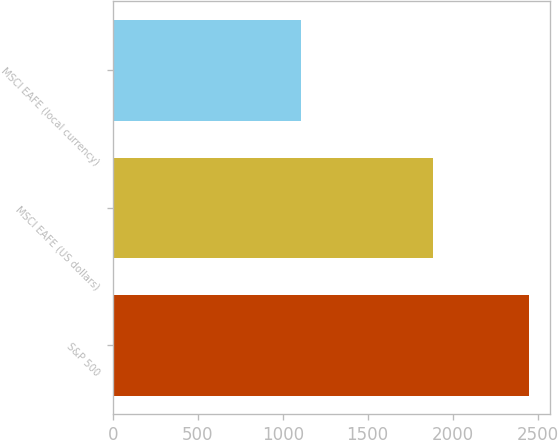Convert chart to OTSL. <chart><loc_0><loc_0><loc_500><loc_500><bar_chart><fcel>S&P 500<fcel>MSCI EAFE (US dollars)<fcel>MSCI EAFE (local currency)<nl><fcel>2448<fcel>1886<fcel>1105<nl></chart> 